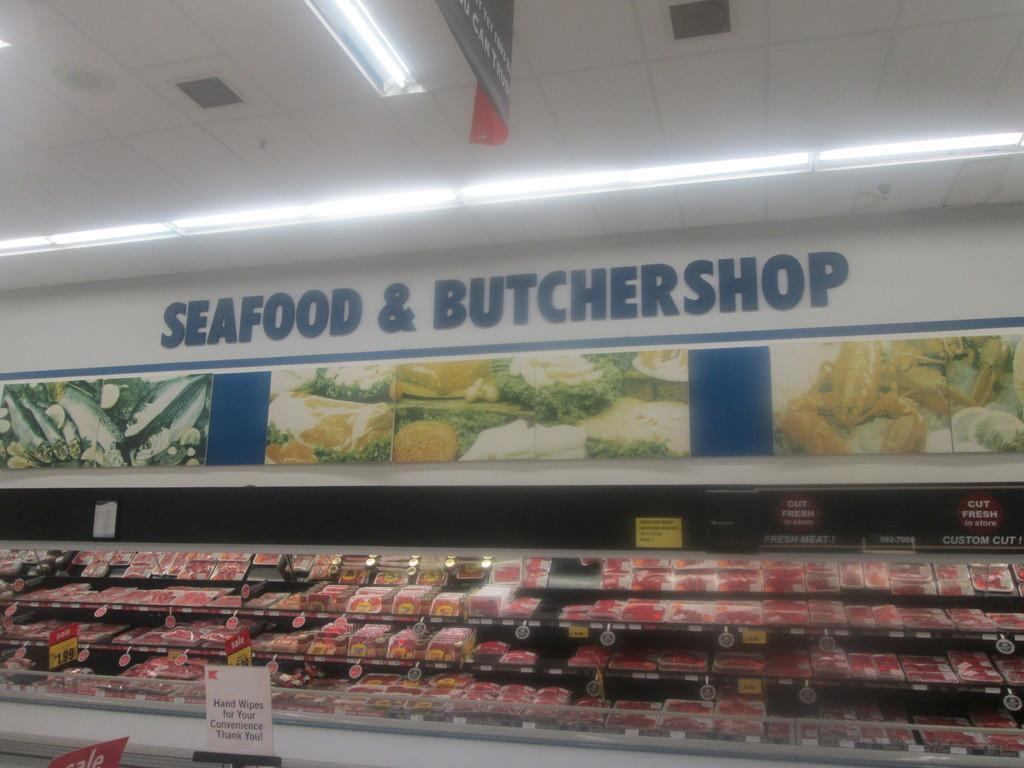<image>
Give a short and clear explanation of the subsequent image. The Seafood and Butcher Shop area of a grocery store has plenty of meat and seafood available 